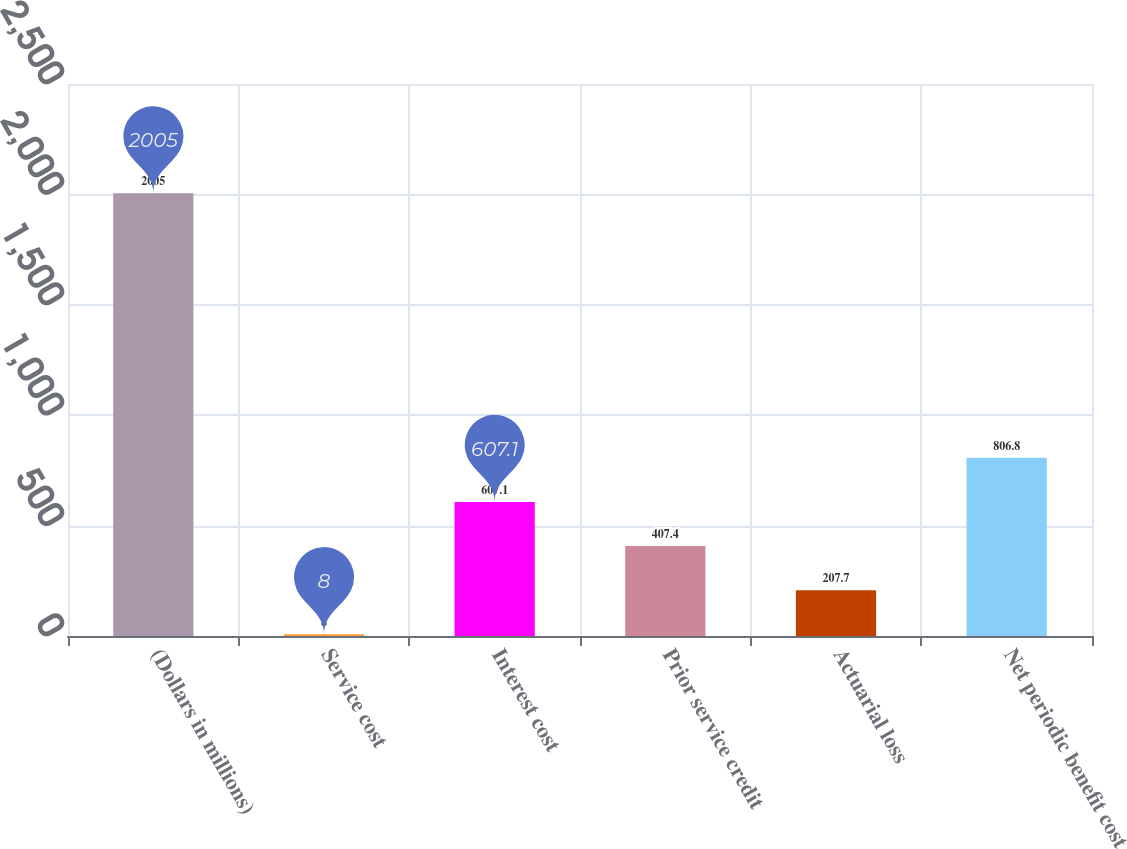Convert chart. <chart><loc_0><loc_0><loc_500><loc_500><bar_chart><fcel>(Dollars in millions)<fcel>Service cost<fcel>Interest cost<fcel>Prior service credit<fcel>Actuarial loss<fcel>Net periodic benefit cost<nl><fcel>2005<fcel>8<fcel>607.1<fcel>407.4<fcel>207.7<fcel>806.8<nl></chart> 